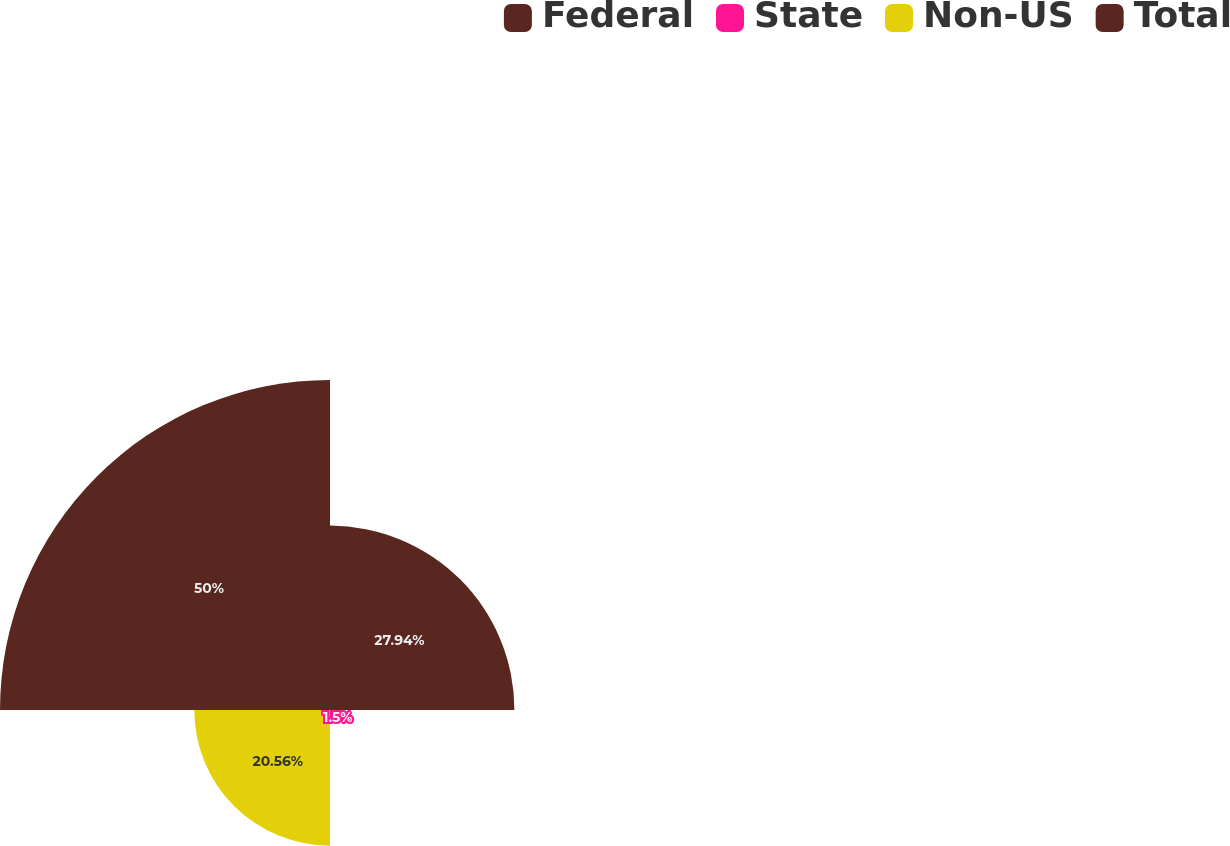Convert chart to OTSL. <chart><loc_0><loc_0><loc_500><loc_500><pie_chart><fcel>Federal<fcel>State<fcel>Non-US<fcel>Total<nl><fcel>27.94%<fcel>1.5%<fcel>20.56%<fcel>50.0%<nl></chart> 